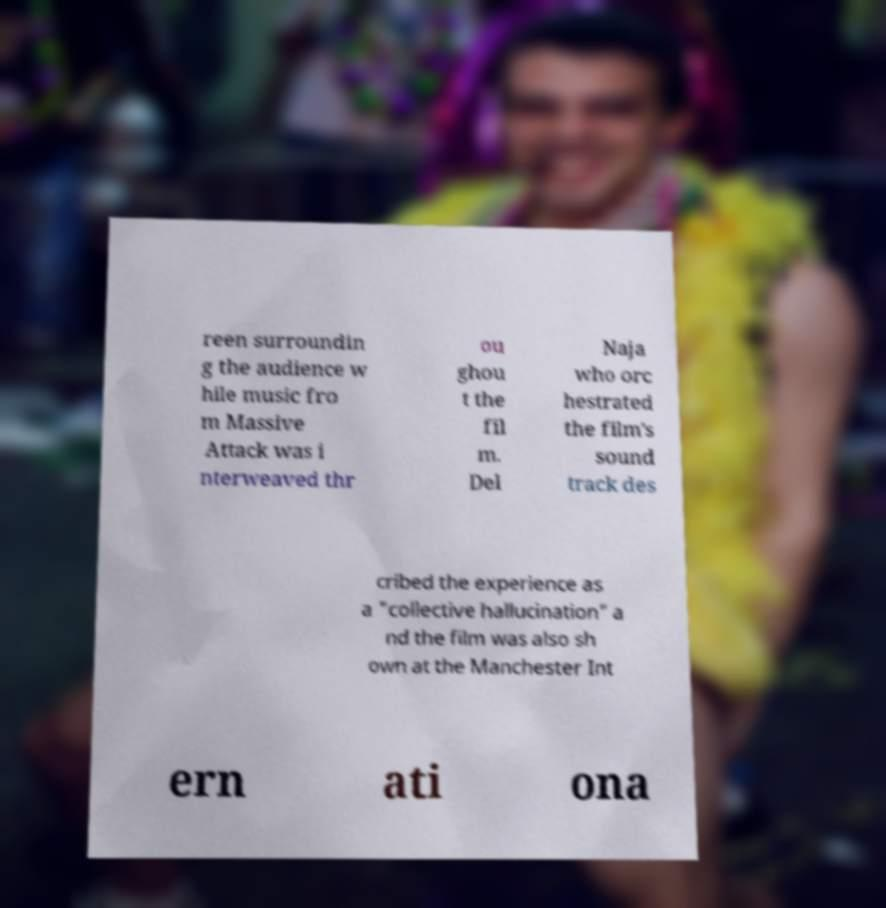I need the written content from this picture converted into text. Can you do that? reen surroundin g the audience w hile music fro m Massive Attack was i nterweaved thr ou ghou t the fil m. Del Naja who orc hestrated the film's sound track des cribed the experience as a "collective hallucination" a nd the film was also sh own at the Manchester Int ern ati ona 